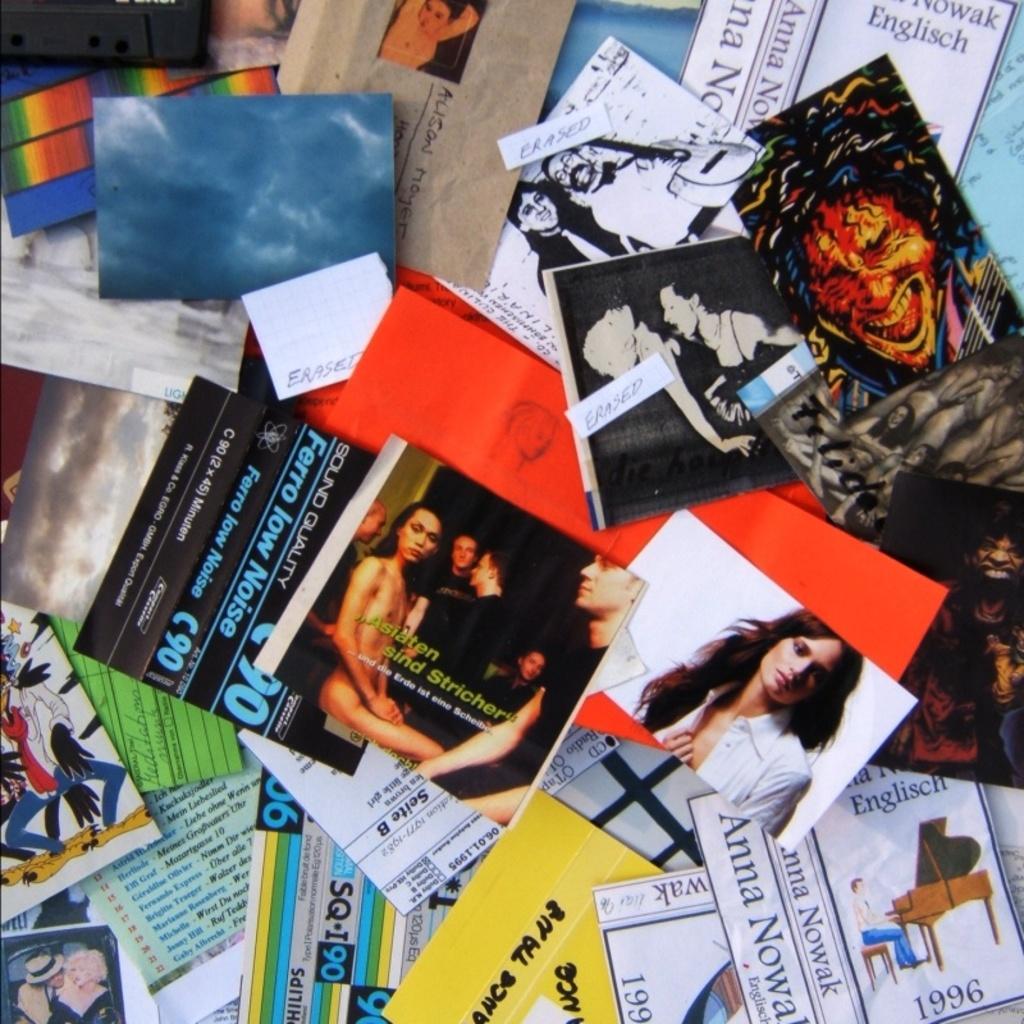What year is shown in the bottom right corner?
Give a very brief answer. 1996. 